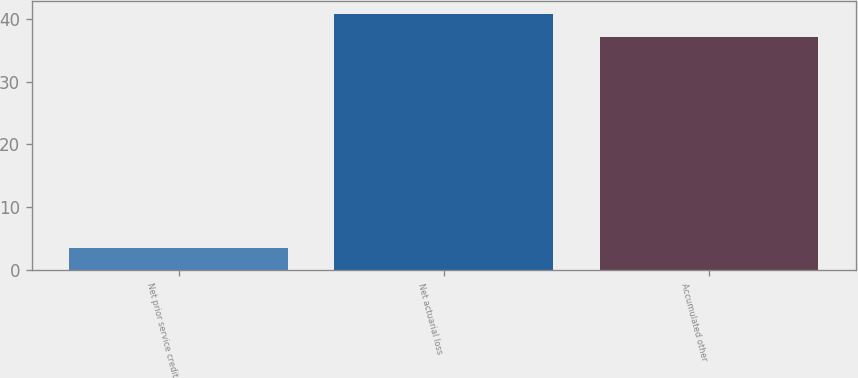Convert chart to OTSL. <chart><loc_0><loc_0><loc_500><loc_500><bar_chart><fcel>Net prior service credit<fcel>Net actuarial loss<fcel>Accumulated other<nl><fcel>3.6<fcel>40.7<fcel>37<nl></chart> 